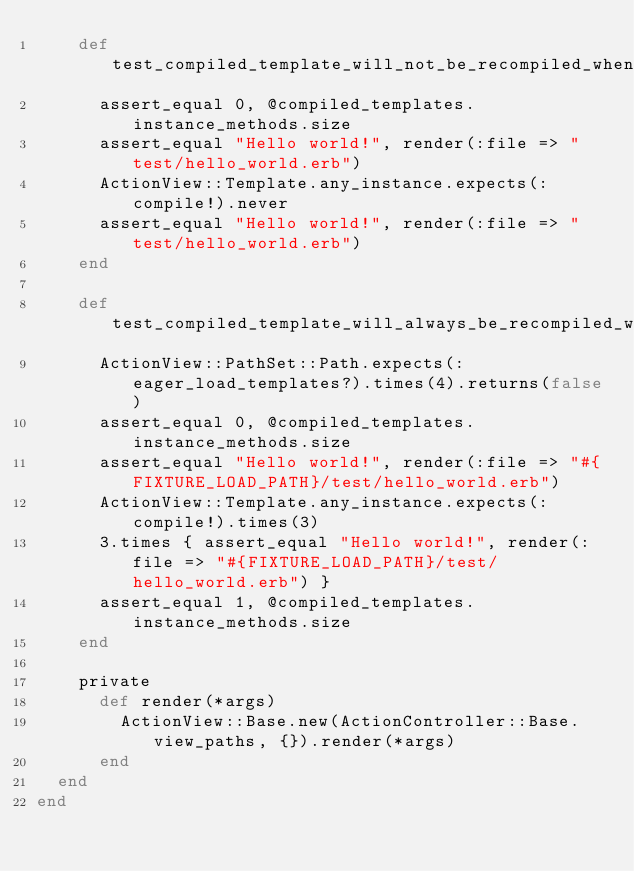Convert code to text. <code><loc_0><loc_0><loc_500><loc_500><_Ruby_>    def test_compiled_template_will_not_be_recompiled_when_rendered_with_identical_local_assigns
      assert_equal 0, @compiled_templates.instance_methods.size
      assert_equal "Hello world!", render(:file => "test/hello_world.erb")
      ActionView::Template.any_instance.expects(:compile!).never
      assert_equal "Hello world!", render(:file => "test/hello_world.erb")
    end

    def test_compiled_template_will_always_be_recompiled_when_eager_loaded_templates_is_off
      ActionView::PathSet::Path.expects(:eager_load_templates?).times(4).returns(false)
      assert_equal 0, @compiled_templates.instance_methods.size
      assert_equal "Hello world!", render(:file => "#{FIXTURE_LOAD_PATH}/test/hello_world.erb")
      ActionView::Template.any_instance.expects(:compile!).times(3)
      3.times { assert_equal "Hello world!", render(:file => "#{FIXTURE_LOAD_PATH}/test/hello_world.erb") }
      assert_equal 1, @compiled_templates.instance_methods.size
    end

    private
      def render(*args)
        ActionView::Base.new(ActionController::Base.view_paths, {}).render(*args)
      end
  end
end
</code> 